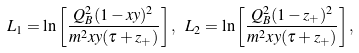Convert formula to latex. <formula><loc_0><loc_0><loc_500><loc_500>L _ { 1 } = \ln \left [ \frac { Q _ { B } ^ { 2 } ( 1 - x y ) ^ { 2 } } { m ^ { 2 } x y ( \tau + z _ { + } ) } \right ] , \ L _ { 2 } = \ln \left [ \frac { Q _ { B } ^ { 2 } ( 1 - z _ { + } ) ^ { 2 } } { m ^ { 2 } x y ( \tau + z _ { + } ) } \right ] , \</formula> 